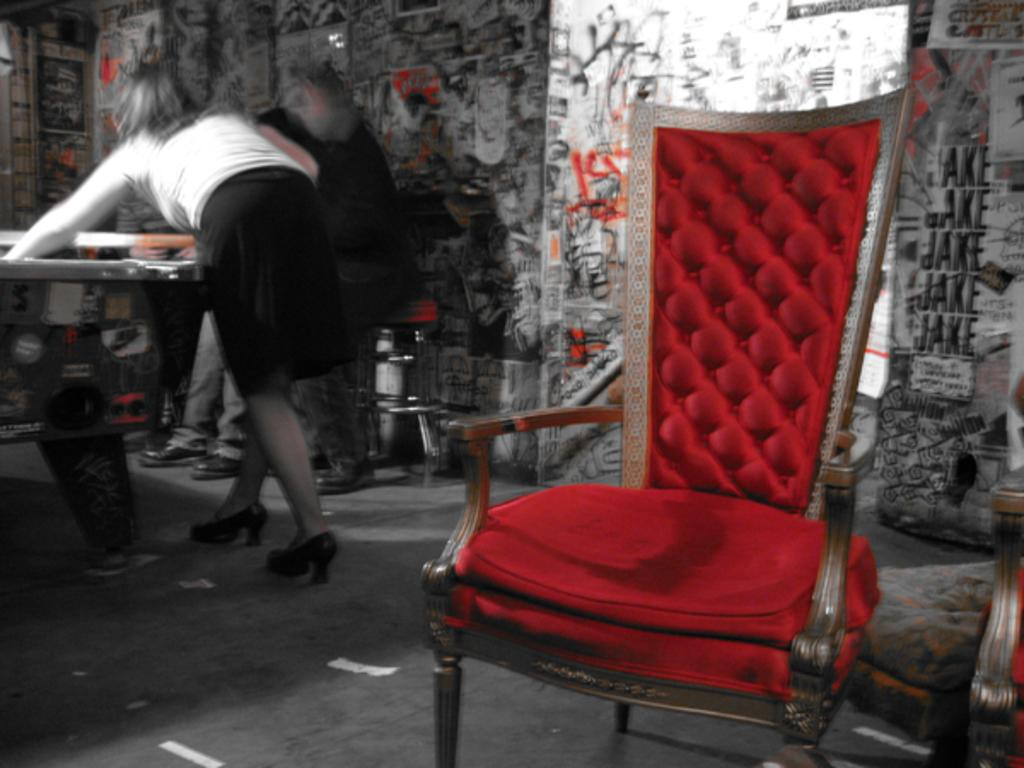What is happening with the people in the image? The people are standing beside a table in the image. What type of furniture is present in the image? There is a chair in the image. What type of lighting is present in the image? There is a lamp in the image. What is on the wall in the image? There is a wall with written text in the image. What type of fish can be seen swimming on the wall in the image? There are no fish present in the image; the wall has written text on it. 